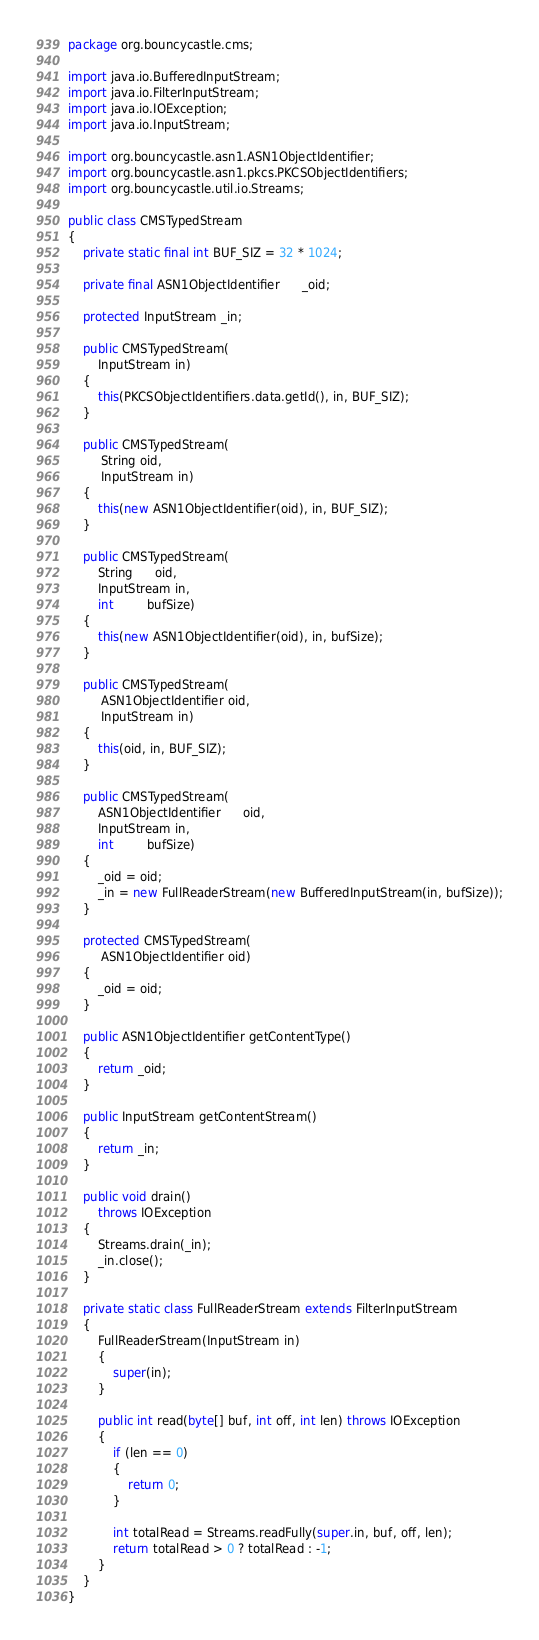<code> <loc_0><loc_0><loc_500><loc_500><_Java_>package org.bouncycastle.cms;

import java.io.BufferedInputStream;
import java.io.FilterInputStream;
import java.io.IOException;
import java.io.InputStream;

import org.bouncycastle.asn1.ASN1ObjectIdentifier;
import org.bouncycastle.asn1.pkcs.PKCSObjectIdentifiers;
import org.bouncycastle.util.io.Streams;

public class CMSTypedStream
{
    private static final int BUF_SIZ = 32 * 1024;
    
    private final ASN1ObjectIdentifier      _oid;

    protected InputStream _in;

    public CMSTypedStream(
        InputStream in)
    {
        this(PKCSObjectIdentifiers.data.getId(), in, BUF_SIZ);
    }
    
    public CMSTypedStream(
         String oid,
         InputStream in)
    {
        this(new ASN1ObjectIdentifier(oid), in, BUF_SIZ);
    }
    
    public CMSTypedStream(
        String      oid,
        InputStream in,
        int         bufSize)
    {
        this(new ASN1ObjectIdentifier(oid), in, bufSize);
    }

    public CMSTypedStream(
         ASN1ObjectIdentifier oid,
         InputStream in)
    {
        this(oid, in, BUF_SIZ);
    }

    public CMSTypedStream(
        ASN1ObjectIdentifier      oid,
        InputStream in,
        int         bufSize)
    {
        _oid = oid;
        _in = new FullReaderStream(new BufferedInputStream(in, bufSize));
    }

    protected CMSTypedStream(
         ASN1ObjectIdentifier oid)
    {
        _oid = oid;
    }

    public ASN1ObjectIdentifier getContentType()
    {
        return _oid;
    }
    
    public InputStream getContentStream()
    {
        return _in;
    }

    public void drain() 
        throws IOException
    {
        Streams.drain(_in);
        _in.close();
    }

    private static class FullReaderStream extends FilterInputStream
    {
        FullReaderStream(InputStream in)
        {
            super(in);
        }

        public int read(byte[] buf, int off, int len) throws IOException
        {
            if (len == 0)
            {
                return 0;
            }

            int totalRead = Streams.readFully(super.in, buf, off, len);
            return totalRead > 0 ? totalRead : -1;
        }
    }
}
</code> 